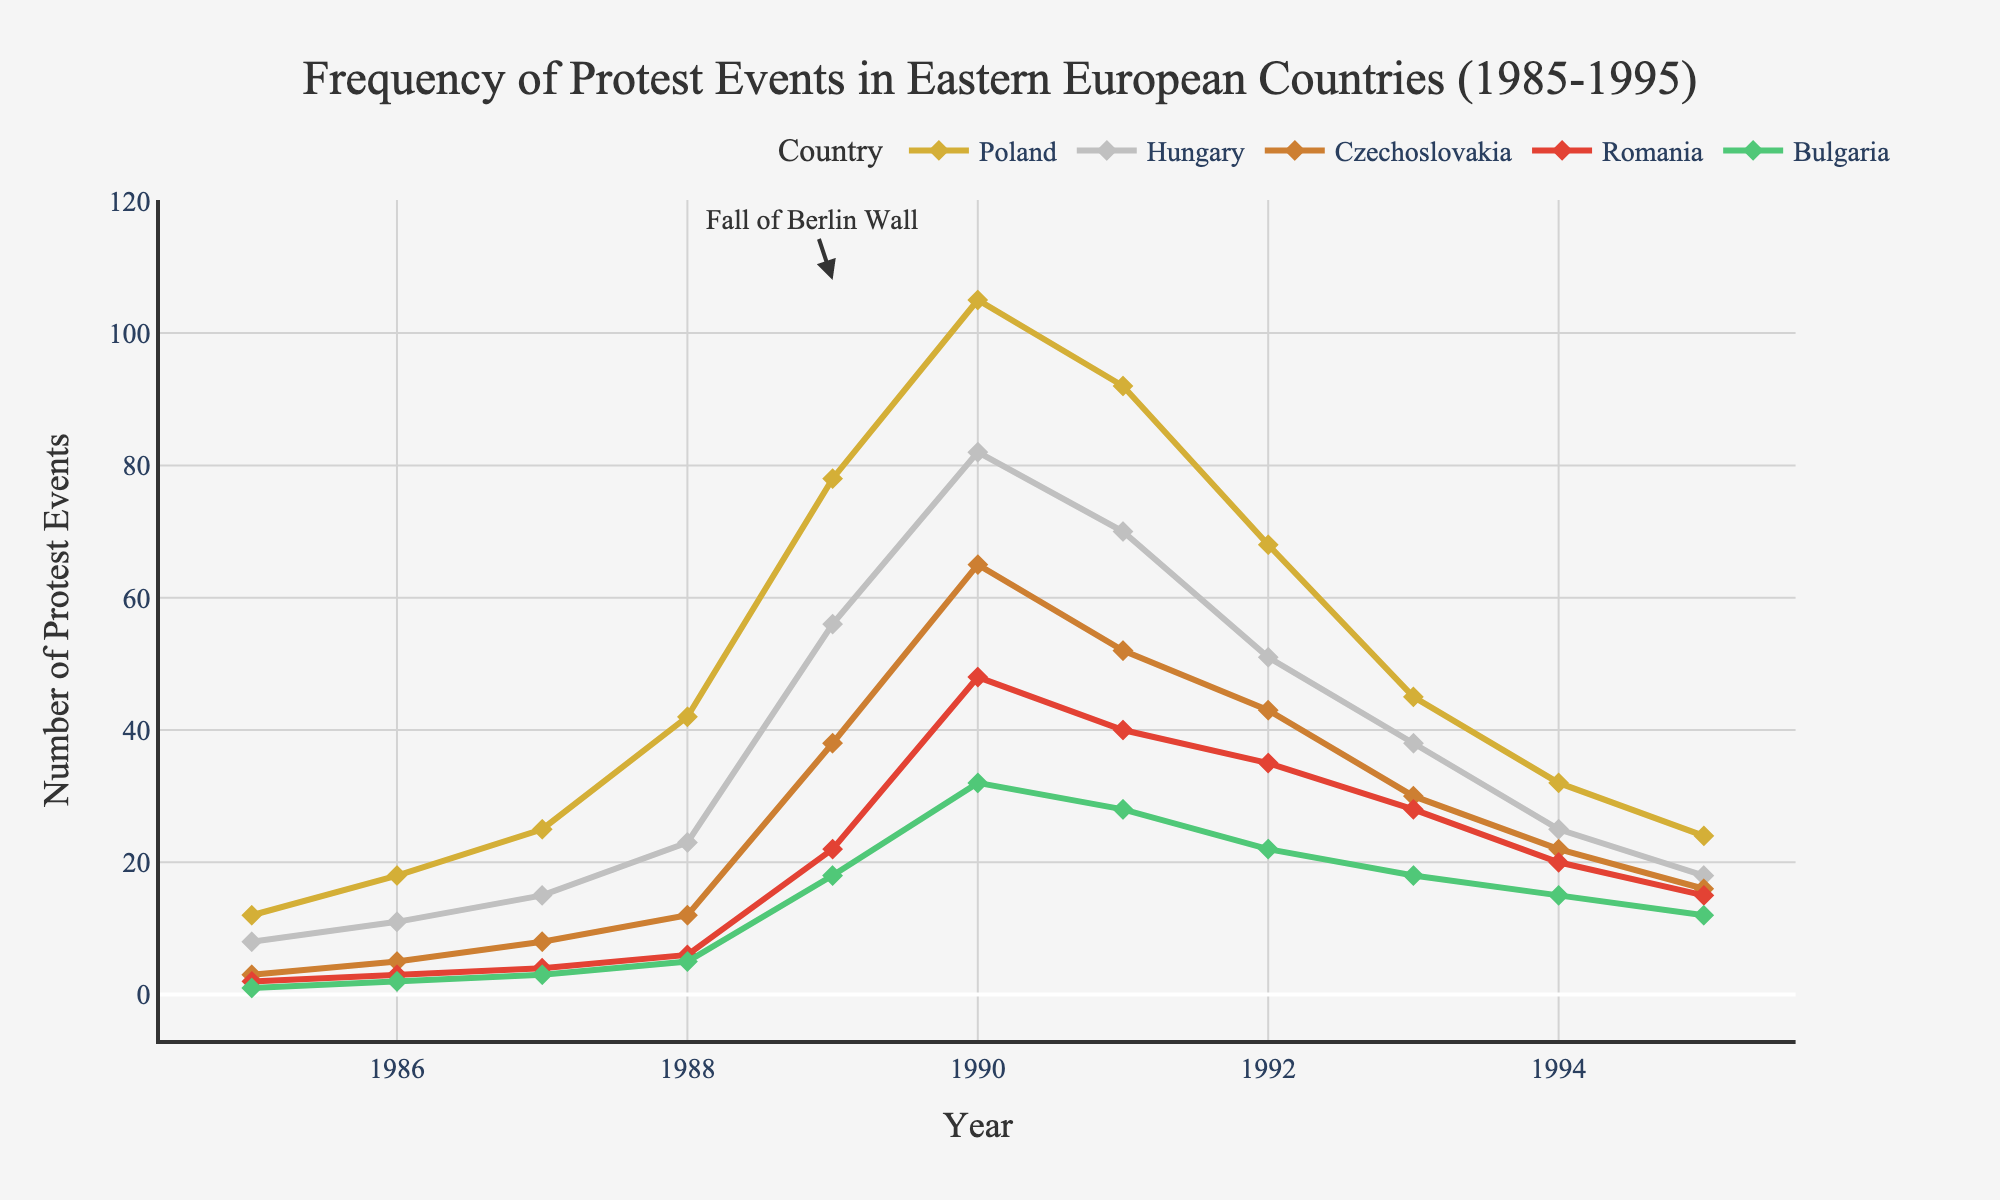What year did Poland experience its peak frequency of protest events? Look for the highest point on the line representing Poland and identify the corresponding year on the x-axis. The peak occurs in 1990.
Answer: 1990 Which country had the greatest increase in protest events between 1988 and 1989? Compare the difference in the number of protest events for each country between 1988 and 1989. Poland increased by 36, Hungary by 33, Czechoslovakia by 26, Romania by 16, and Bulgaria by 13. Poland had the greatest increase.
Answer: Poland What is the overall trend for protest events in Romania from 1990 to 1995? Observe the line representing Romania from 1990 to 1995. The trend shows a consistent decline in the number of protest events.
Answer: Declining Which years did Hungary experience a higher number of protest events than Czechoslovakia? Compare the lines for Hungary and Czechoslovakia year by year to see when Hungary's values are higher. This occurs in 1985, 1986, 1987, 1988, 1989, and 1991.
Answer: 1985, 1986, 1987, 1988, 1989, 1991 What was the median number of protest events in Bulgaria during the decade? Identify the values for Bulgaria from 1985 to 1995 and find the middle value in the ordered list (1, 2, 3, 5, 18, 22, 28, 32, 15, 12). The middle value in the list is 15 (1994).
Answer: 15 Did Czechoslovakia ever surpass Hungary in the number of protest events? If yes, in which years? Compare the values between Czechoslovakia and Hungary for each year. Czechoslovakia surpassed Hungary in 1990, 1992, 1993, 1994, and 1995.
Answer: 1990, 1992, 1993, 1994, 1995 How does the trend in protest events from 1989 to 1990 in Romania compare to that in Poland? Observe the slope and direction of the line segments for Romania and Poland between 1989 and 1990. Both countries show an increase, but Poland’s increase is much sharper.
Answer: Both increased, but Poland increased more sharply Which country had the lowest number of protest events in 1995, and what was that number? Compare the values for all countries in 1995 and identify the lowest value. Bulgaria had the lowest with 12 events.
Answer: Bulgaria, 12 